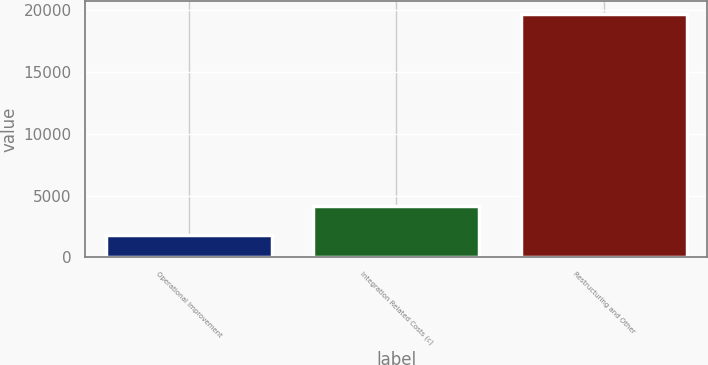Convert chart to OTSL. <chart><loc_0><loc_0><loc_500><loc_500><bar_chart><fcel>Operational Improvement<fcel>Integration Related Costs (c)<fcel>Restructuring and Other<nl><fcel>1802<fcel>4179<fcel>19711<nl></chart> 